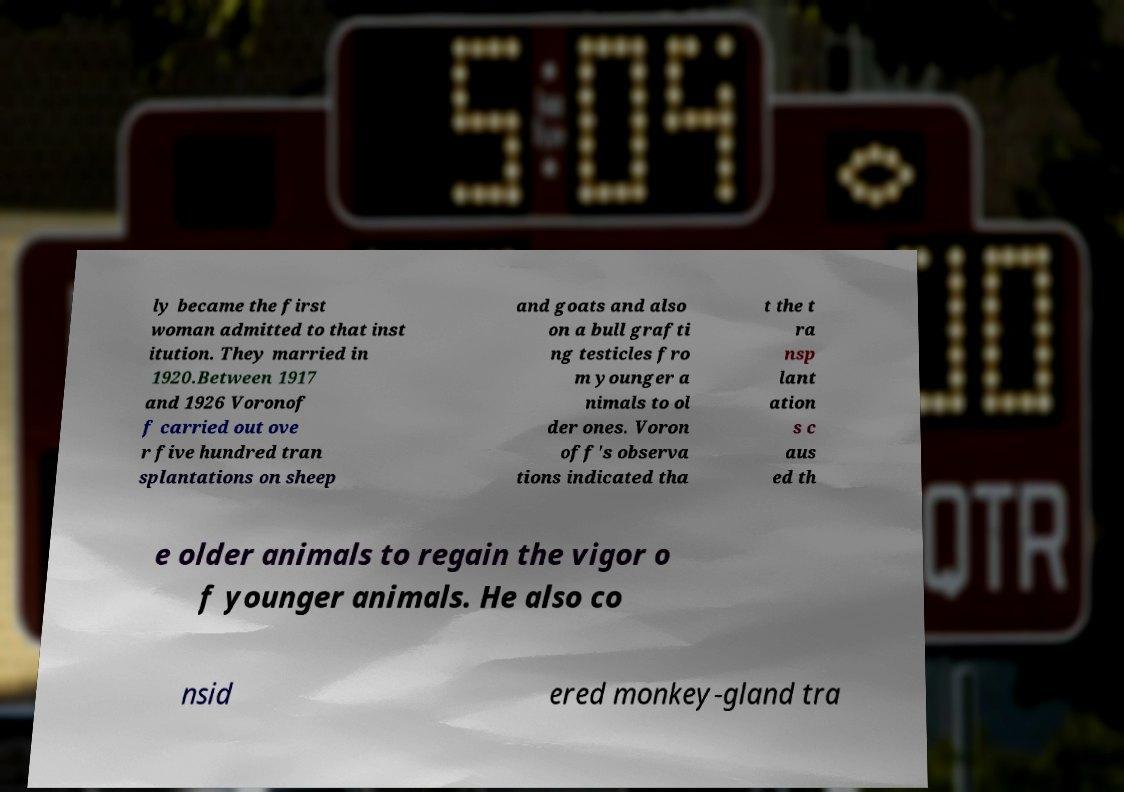Could you assist in decoding the text presented in this image and type it out clearly? ly became the first woman admitted to that inst itution. They married in 1920.Between 1917 and 1926 Voronof f carried out ove r five hundred tran splantations on sheep and goats and also on a bull grafti ng testicles fro m younger a nimals to ol der ones. Voron off's observa tions indicated tha t the t ra nsp lant ation s c aus ed th e older animals to regain the vigor o f younger animals. He also co nsid ered monkey-gland tra 